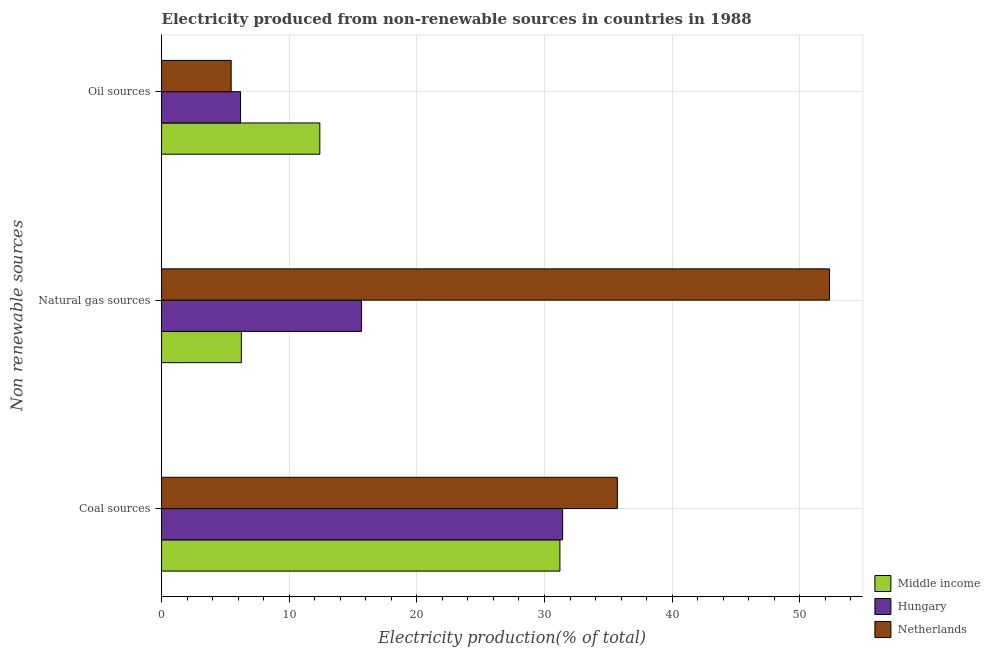How many different coloured bars are there?
Your answer should be very brief. 3. Are the number of bars per tick equal to the number of legend labels?
Ensure brevity in your answer.  Yes. How many bars are there on the 3rd tick from the bottom?
Offer a terse response. 3. What is the label of the 3rd group of bars from the top?
Provide a succinct answer. Coal sources. What is the percentage of electricity produced by natural gas in Netherlands?
Offer a terse response. 52.33. Across all countries, what is the maximum percentage of electricity produced by coal?
Your answer should be compact. 35.71. Across all countries, what is the minimum percentage of electricity produced by coal?
Ensure brevity in your answer.  31.21. In which country was the percentage of electricity produced by coal maximum?
Offer a very short reply. Netherlands. What is the total percentage of electricity produced by coal in the graph?
Offer a very short reply. 98.35. What is the difference between the percentage of electricity produced by natural gas in Netherlands and that in Hungary?
Your answer should be compact. 36.66. What is the difference between the percentage of electricity produced by natural gas in Hungary and the percentage of electricity produced by oil sources in Middle income?
Offer a terse response. 3.27. What is the average percentage of electricity produced by natural gas per country?
Give a very brief answer. 24.75. What is the difference between the percentage of electricity produced by coal and percentage of electricity produced by oil sources in Middle income?
Keep it short and to the point. 18.81. In how many countries, is the percentage of electricity produced by oil sources greater than 34 %?
Your answer should be compact. 0. What is the ratio of the percentage of electricity produced by oil sources in Middle income to that in Hungary?
Your answer should be compact. 2. Is the difference between the percentage of electricity produced by coal in Netherlands and Hungary greater than the difference between the percentage of electricity produced by natural gas in Netherlands and Hungary?
Ensure brevity in your answer.  No. What is the difference between the highest and the second highest percentage of electricity produced by natural gas?
Provide a succinct answer. 36.66. What is the difference between the highest and the lowest percentage of electricity produced by coal?
Your answer should be very brief. 4.5. Is it the case that in every country, the sum of the percentage of electricity produced by coal and percentage of electricity produced by natural gas is greater than the percentage of electricity produced by oil sources?
Offer a very short reply. Yes. How many bars are there?
Your answer should be compact. 9. Does the graph contain any zero values?
Your answer should be very brief. No. How many legend labels are there?
Make the answer very short. 3. How are the legend labels stacked?
Keep it short and to the point. Vertical. What is the title of the graph?
Your answer should be compact. Electricity produced from non-renewable sources in countries in 1988. What is the label or title of the X-axis?
Ensure brevity in your answer.  Electricity production(% of total). What is the label or title of the Y-axis?
Provide a short and direct response. Non renewable sources. What is the Electricity production(% of total) of Middle income in Coal sources?
Your answer should be very brief. 31.21. What is the Electricity production(% of total) of Hungary in Coal sources?
Give a very brief answer. 31.42. What is the Electricity production(% of total) in Netherlands in Coal sources?
Make the answer very short. 35.71. What is the Electricity production(% of total) in Middle income in Natural gas sources?
Provide a succinct answer. 6.25. What is the Electricity production(% of total) of Hungary in Natural gas sources?
Make the answer very short. 15.67. What is the Electricity production(% of total) in Netherlands in Natural gas sources?
Your response must be concise. 52.33. What is the Electricity production(% of total) of Middle income in Oil sources?
Your answer should be compact. 12.4. What is the Electricity production(% of total) in Hungary in Oil sources?
Your response must be concise. 6.19. What is the Electricity production(% of total) of Netherlands in Oil sources?
Provide a short and direct response. 5.45. Across all Non renewable sources, what is the maximum Electricity production(% of total) in Middle income?
Provide a succinct answer. 31.21. Across all Non renewable sources, what is the maximum Electricity production(% of total) in Hungary?
Provide a succinct answer. 31.42. Across all Non renewable sources, what is the maximum Electricity production(% of total) in Netherlands?
Keep it short and to the point. 52.33. Across all Non renewable sources, what is the minimum Electricity production(% of total) in Middle income?
Offer a terse response. 6.25. Across all Non renewable sources, what is the minimum Electricity production(% of total) of Hungary?
Your answer should be compact. 6.19. Across all Non renewable sources, what is the minimum Electricity production(% of total) of Netherlands?
Keep it short and to the point. 5.45. What is the total Electricity production(% of total) of Middle income in the graph?
Your answer should be compact. 49.86. What is the total Electricity production(% of total) of Hungary in the graph?
Provide a succinct answer. 53.28. What is the total Electricity production(% of total) in Netherlands in the graph?
Make the answer very short. 93.5. What is the difference between the Electricity production(% of total) of Middle income in Coal sources and that in Natural gas sources?
Provide a succinct answer. 24.96. What is the difference between the Electricity production(% of total) in Hungary in Coal sources and that in Natural gas sources?
Make the answer very short. 15.76. What is the difference between the Electricity production(% of total) of Netherlands in Coal sources and that in Natural gas sources?
Your answer should be compact. -16.62. What is the difference between the Electricity production(% of total) of Middle income in Coal sources and that in Oil sources?
Provide a short and direct response. 18.81. What is the difference between the Electricity production(% of total) in Hungary in Coal sources and that in Oil sources?
Ensure brevity in your answer.  25.24. What is the difference between the Electricity production(% of total) of Netherlands in Coal sources and that in Oil sources?
Ensure brevity in your answer.  30.26. What is the difference between the Electricity production(% of total) in Middle income in Natural gas sources and that in Oil sources?
Provide a succinct answer. -6.15. What is the difference between the Electricity production(% of total) of Hungary in Natural gas sources and that in Oil sources?
Your response must be concise. 9.48. What is the difference between the Electricity production(% of total) of Netherlands in Natural gas sources and that in Oil sources?
Your answer should be compact. 46.88. What is the difference between the Electricity production(% of total) in Middle income in Coal sources and the Electricity production(% of total) in Hungary in Natural gas sources?
Provide a short and direct response. 15.54. What is the difference between the Electricity production(% of total) in Middle income in Coal sources and the Electricity production(% of total) in Netherlands in Natural gas sources?
Your response must be concise. -21.12. What is the difference between the Electricity production(% of total) of Hungary in Coal sources and the Electricity production(% of total) of Netherlands in Natural gas sources?
Offer a very short reply. -20.91. What is the difference between the Electricity production(% of total) in Middle income in Coal sources and the Electricity production(% of total) in Hungary in Oil sources?
Your answer should be compact. 25.02. What is the difference between the Electricity production(% of total) in Middle income in Coal sources and the Electricity production(% of total) in Netherlands in Oil sources?
Provide a succinct answer. 25.76. What is the difference between the Electricity production(% of total) in Hungary in Coal sources and the Electricity production(% of total) in Netherlands in Oil sources?
Provide a succinct answer. 25.97. What is the difference between the Electricity production(% of total) of Middle income in Natural gas sources and the Electricity production(% of total) of Hungary in Oil sources?
Ensure brevity in your answer.  0.06. What is the difference between the Electricity production(% of total) in Middle income in Natural gas sources and the Electricity production(% of total) in Netherlands in Oil sources?
Make the answer very short. 0.8. What is the difference between the Electricity production(% of total) of Hungary in Natural gas sources and the Electricity production(% of total) of Netherlands in Oil sources?
Make the answer very short. 10.21. What is the average Electricity production(% of total) of Middle income per Non renewable sources?
Provide a succinct answer. 16.62. What is the average Electricity production(% of total) in Hungary per Non renewable sources?
Give a very brief answer. 17.76. What is the average Electricity production(% of total) in Netherlands per Non renewable sources?
Offer a very short reply. 31.17. What is the difference between the Electricity production(% of total) in Middle income and Electricity production(% of total) in Hungary in Coal sources?
Your answer should be very brief. -0.21. What is the difference between the Electricity production(% of total) of Middle income and Electricity production(% of total) of Netherlands in Coal sources?
Provide a succinct answer. -4.5. What is the difference between the Electricity production(% of total) in Hungary and Electricity production(% of total) in Netherlands in Coal sources?
Offer a very short reply. -4.29. What is the difference between the Electricity production(% of total) in Middle income and Electricity production(% of total) in Hungary in Natural gas sources?
Provide a succinct answer. -9.42. What is the difference between the Electricity production(% of total) in Middle income and Electricity production(% of total) in Netherlands in Natural gas sources?
Keep it short and to the point. -46.08. What is the difference between the Electricity production(% of total) of Hungary and Electricity production(% of total) of Netherlands in Natural gas sources?
Your answer should be compact. -36.66. What is the difference between the Electricity production(% of total) in Middle income and Electricity production(% of total) in Hungary in Oil sources?
Keep it short and to the point. 6.21. What is the difference between the Electricity production(% of total) of Middle income and Electricity production(% of total) of Netherlands in Oil sources?
Provide a succinct answer. 6.95. What is the difference between the Electricity production(% of total) in Hungary and Electricity production(% of total) in Netherlands in Oil sources?
Provide a short and direct response. 0.74. What is the ratio of the Electricity production(% of total) in Middle income in Coal sources to that in Natural gas sources?
Keep it short and to the point. 4.99. What is the ratio of the Electricity production(% of total) in Hungary in Coal sources to that in Natural gas sources?
Ensure brevity in your answer.  2.01. What is the ratio of the Electricity production(% of total) in Netherlands in Coal sources to that in Natural gas sources?
Keep it short and to the point. 0.68. What is the ratio of the Electricity production(% of total) of Middle income in Coal sources to that in Oil sources?
Your response must be concise. 2.52. What is the ratio of the Electricity production(% of total) in Hungary in Coal sources to that in Oil sources?
Your response must be concise. 5.08. What is the ratio of the Electricity production(% of total) of Netherlands in Coal sources to that in Oil sources?
Your response must be concise. 6.55. What is the ratio of the Electricity production(% of total) in Middle income in Natural gas sources to that in Oil sources?
Provide a short and direct response. 0.5. What is the ratio of the Electricity production(% of total) in Hungary in Natural gas sources to that in Oil sources?
Your answer should be very brief. 2.53. What is the ratio of the Electricity production(% of total) of Netherlands in Natural gas sources to that in Oil sources?
Keep it short and to the point. 9.6. What is the difference between the highest and the second highest Electricity production(% of total) in Middle income?
Offer a terse response. 18.81. What is the difference between the highest and the second highest Electricity production(% of total) of Hungary?
Offer a very short reply. 15.76. What is the difference between the highest and the second highest Electricity production(% of total) of Netherlands?
Make the answer very short. 16.62. What is the difference between the highest and the lowest Electricity production(% of total) in Middle income?
Keep it short and to the point. 24.96. What is the difference between the highest and the lowest Electricity production(% of total) in Hungary?
Provide a succinct answer. 25.24. What is the difference between the highest and the lowest Electricity production(% of total) in Netherlands?
Offer a terse response. 46.88. 